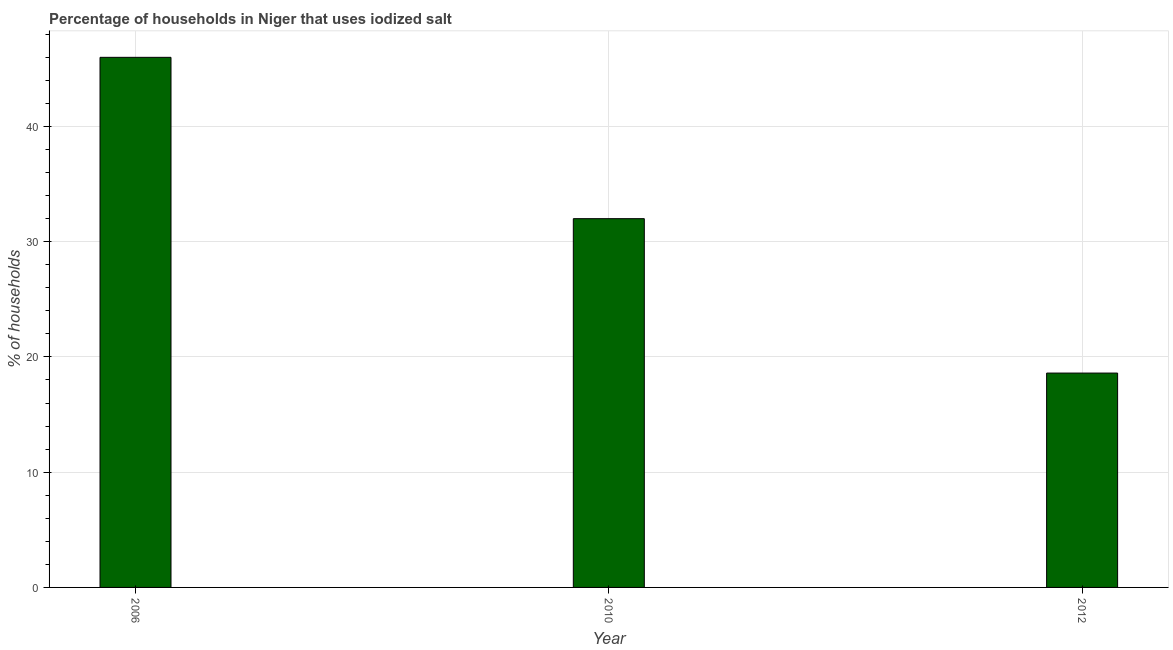Does the graph contain any zero values?
Offer a very short reply. No. Does the graph contain grids?
Provide a succinct answer. Yes. What is the title of the graph?
Keep it short and to the point. Percentage of households in Niger that uses iodized salt. What is the label or title of the Y-axis?
Make the answer very short. % of households. Across all years, what is the minimum percentage of households where iodized salt is consumed?
Ensure brevity in your answer.  18.6. In which year was the percentage of households where iodized salt is consumed maximum?
Offer a very short reply. 2006. What is the sum of the percentage of households where iodized salt is consumed?
Make the answer very short. 96.6. What is the difference between the percentage of households where iodized salt is consumed in 2010 and 2012?
Provide a short and direct response. 13.4. What is the average percentage of households where iodized salt is consumed per year?
Keep it short and to the point. 32.2. Do a majority of the years between 2006 and 2012 (inclusive) have percentage of households where iodized salt is consumed greater than 22 %?
Your response must be concise. Yes. What is the ratio of the percentage of households where iodized salt is consumed in 2006 to that in 2010?
Your answer should be compact. 1.44. What is the difference between the highest and the second highest percentage of households where iodized salt is consumed?
Your response must be concise. 14. What is the difference between the highest and the lowest percentage of households where iodized salt is consumed?
Your answer should be compact. 27.4. What is the difference between two consecutive major ticks on the Y-axis?
Your response must be concise. 10. Are the values on the major ticks of Y-axis written in scientific E-notation?
Provide a succinct answer. No. What is the % of households of 2010?
Keep it short and to the point. 32. What is the % of households of 2012?
Your answer should be compact. 18.6. What is the difference between the % of households in 2006 and 2012?
Your answer should be compact. 27.4. What is the difference between the % of households in 2010 and 2012?
Offer a very short reply. 13.4. What is the ratio of the % of households in 2006 to that in 2010?
Provide a short and direct response. 1.44. What is the ratio of the % of households in 2006 to that in 2012?
Provide a succinct answer. 2.47. What is the ratio of the % of households in 2010 to that in 2012?
Provide a succinct answer. 1.72. 